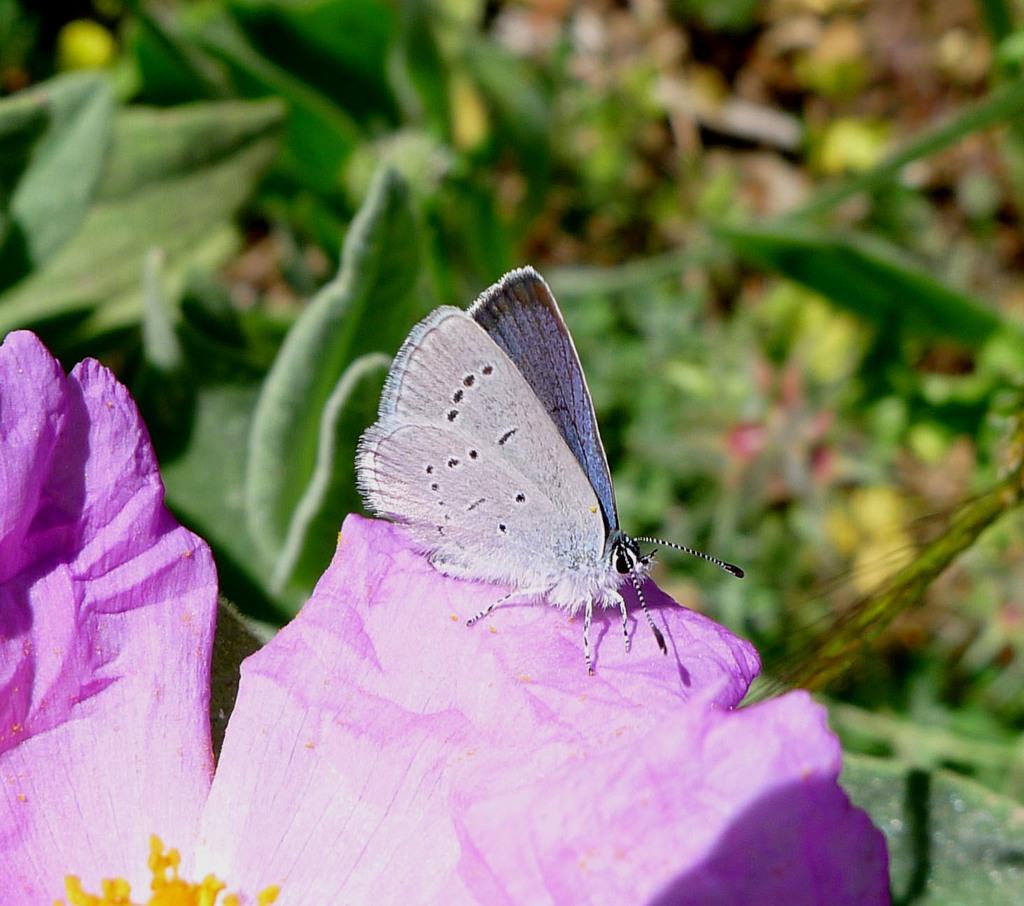How would you summarize this image in a sentence or two? In this image I can see the butterfly on the pink color flower. To the side there are few more plants and it is blurry. 